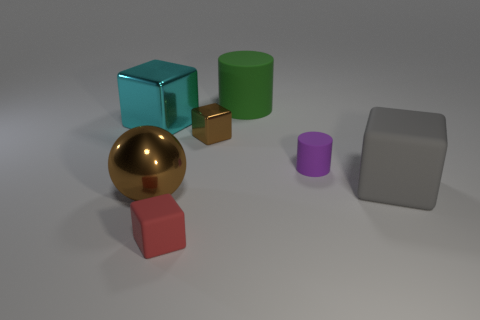Subtract all brown blocks. How many blocks are left? 3 Subtract all large gray cubes. How many cubes are left? 3 Add 2 rubber blocks. How many objects exist? 9 Subtract 1 cylinders. How many cylinders are left? 1 Subtract all yellow cylinders. Subtract all yellow balls. How many cylinders are left? 2 Subtract all cyan cylinders. How many brown cubes are left? 1 Subtract 1 cyan cubes. How many objects are left? 6 Subtract all spheres. How many objects are left? 6 Subtract all tiny rubber blocks. Subtract all tiny brown metal blocks. How many objects are left? 5 Add 7 big brown metal objects. How many big brown metal objects are left? 8 